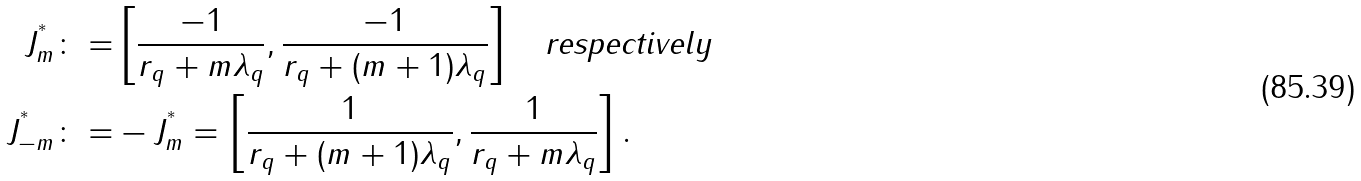<formula> <loc_0><loc_0><loc_500><loc_500>J _ { m } ^ { ^ { * } } \colon = & \left [ \frac { - 1 } { r _ { q } + m \lambda _ { q } } , \frac { - 1 } { r _ { q } + ( m + 1 ) \lambda _ { q } } \right ] \quad \text {respectively} \\ J _ { - m } ^ { ^ { * } } \colon = & - J _ { m } ^ { ^ { * } } = \left [ \frac { 1 } { r _ { q } + ( m + 1 ) \lambda _ { q } } , \frac { 1 } { r _ { q } + m \lambda _ { q } } \right ] .</formula> 